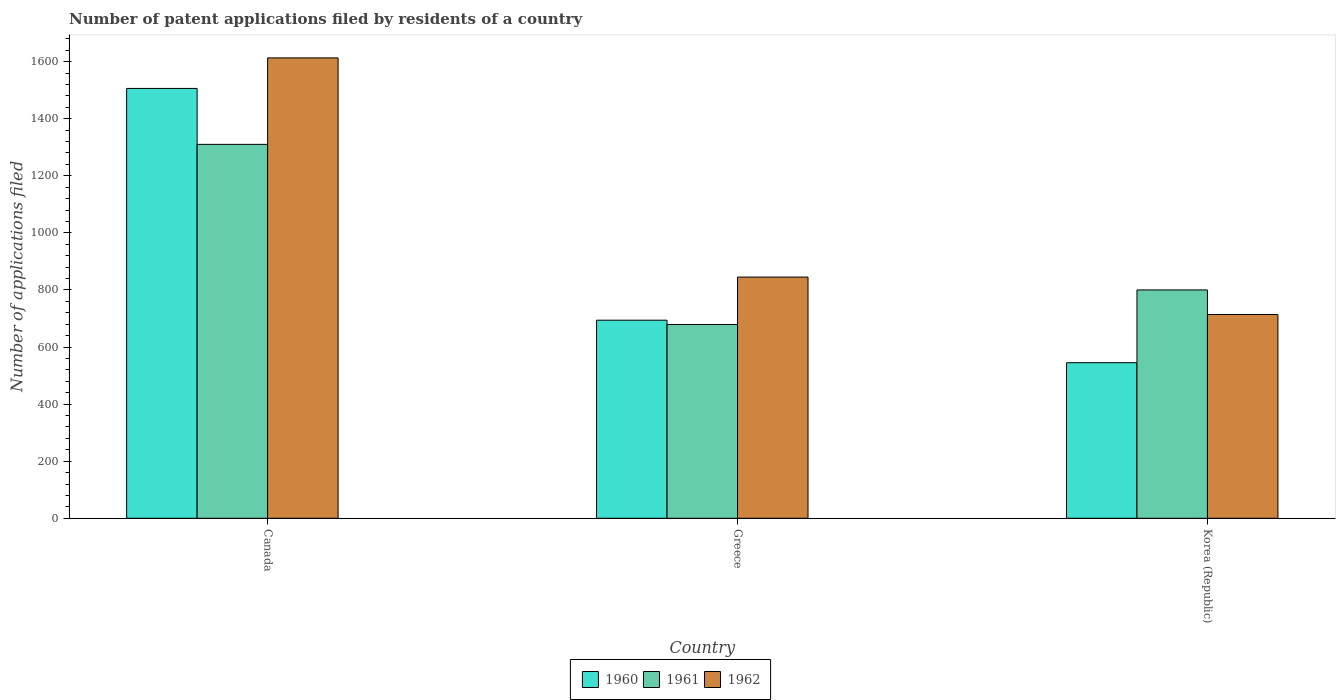Are the number of bars on each tick of the X-axis equal?
Provide a short and direct response. Yes. In how many cases, is the number of bars for a given country not equal to the number of legend labels?
Provide a succinct answer. 0. What is the number of applications filed in 1962 in Korea (Republic)?
Give a very brief answer. 714. Across all countries, what is the maximum number of applications filed in 1961?
Give a very brief answer. 1310. Across all countries, what is the minimum number of applications filed in 1961?
Your answer should be very brief. 679. What is the total number of applications filed in 1962 in the graph?
Make the answer very short. 3172. What is the difference between the number of applications filed in 1960 in Canada and that in Greece?
Your answer should be compact. 812. What is the difference between the number of applications filed in 1961 in Korea (Republic) and the number of applications filed in 1962 in Canada?
Offer a very short reply. -813. What is the average number of applications filed in 1961 per country?
Your answer should be compact. 929.67. What is the difference between the number of applications filed of/in 1962 and number of applications filed of/in 1961 in Canada?
Ensure brevity in your answer.  303. What is the ratio of the number of applications filed in 1962 in Canada to that in Korea (Republic)?
Your answer should be very brief. 2.26. What is the difference between the highest and the second highest number of applications filed in 1962?
Give a very brief answer. -131. What is the difference between the highest and the lowest number of applications filed in 1961?
Offer a very short reply. 631. Is the sum of the number of applications filed in 1961 in Canada and Korea (Republic) greater than the maximum number of applications filed in 1962 across all countries?
Provide a succinct answer. Yes. What does the 2nd bar from the right in Canada represents?
Your response must be concise. 1961. How many bars are there?
Your response must be concise. 9. Are all the bars in the graph horizontal?
Offer a terse response. No. How many countries are there in the graph?
Your answer should be very brief. 3. What is the difference between two consecutive major ticks on the Y-axis?
Make the answer very short. 200. Are the values on the major ticks of Y-axis written in scientific E-notation?
Your answer should be very brief. No. How many legend labels are there?
Provide a short and direct response. 3. What is the title of the graph?
Offer a very short reply. Number of patent applications filed by residents of a country. What is the label or title of the X-axis?
Make the answer very short. Country. What is the label or title of the Y-axis?
Provide a succinct answer. Number of applications filed. What is the Number of applications filed in 1960 in Canada?
Your answer should be compact. 1506. What is the Number of applications filed of 1961 in Canada?
Make the answer very short. 1310. What is the Number of applications filed in 1962 in Canada?
Provide a succinct answer. 1613. What is the Number of applications filed in 1960 in Greece?
Your response must be concise. 694. What is the Number of applications filed of 1961 in Greece?
Give a very brief answer. 679. What is the Number of applications filed in 1962 in Greece?
Offer a terse response. 845. What is the Number of applications filed of 1960 in Korea (Republic)?
Provide a succinct answer. 545. What is the Number of applications filed of 1961 in Korea (Republic)?
Offer a very short reply. 800. What is the Number of applications filed of 1962 in Korea (Republic)?
Your answer should be compact. 714. Across all countries, what is the maximum Number of applications filed in 1960?
Your response must be concise. 1506. Across all countries, what is the maximum Number of applications filed of 1961?
Provide a succinct answer. 1310. Across all countries, what is the maximum Number of applications filed of 1962?
Your answer should be compact. 1613. Across all countries, what is the minimum Number of applications filed in 1960?
Your answer should be very brief. 545. Across all countries, what is the minimum Number of applications filed in 1961?
Provide a short and direct response. 679. Across all countries, what is the minimum Number of applications filed of 1962?
Offer a terse response. 714. What is the total Number of applications filed of 1960 in the graph?
Ensure brevity in your answer.  2745. What is the total Number of applications filed of 1961 in the graph?
Offer a terse response. 2789. What is the total Number of applications filed of 1962 in the graph?
Ensure brevity in your answer.  3172. What is the difference between the Number of applications filed in 1960 in Canada and that in Greece?
Make the answer very short. 812. What is the difference between the Number of applications filed in 1961 in Canada and that in Greece?
Your answer should be compact. 631. What is the difference between the Number of applications filed in 1962 in Canada and that in Greece?
Give a very brief answer. 768. What is the difference between the Number of applications filed in 1960 in Canada and that in Korea (Republic)?
Ensure brevity in your answer.  961. What is the difference between the Number of applications filed of 1961 in Canada and that in Korea (Republic)?
Give a very brief answer. 510. What is the difference between the Number of applications filed of 1962 in Canada and that in Korea (Republic)?
Provide a short and direct response. 899. What is the difference between the Number of applications filed in 1960 in Greece and that in Korea (Republic)?
Ensure brevity in your answer.  149. What is the difference between the Number of applications filed of 1961 in Greece and that in Korea (Republic)?
Your response must be concise. -121. What is the difference between the Number of applications filed in 1962 in Greece and that in Korea (Republic)?
Give a very brief answer. 131. What is the difference between the Number of applications filed of 1960 in Canada and the Number of applications filed of 1961 in Greece?
Keep it short and to the point. 827. What is the difference between the Number of applications filed of 1960 in Canada and the Number of applications filed of 1962 in Greece?
Offer a terse response. 661. What is the difference between the Number of applications filed in 1961 in Canada and the Number of applications filed in 1962 in Greece?
Offer a very short reply. 465. What is the difference between the Number of applications filed of 1960 in Canada and the Number of applications filed of 1961 in Korea (Republic)?
Ensure brevity in your answer.  706. What is the difference between the Number of applications filed of 1960 in Canada and the Number of applications filed of 1962 in Korea (Republic)?
Your answer should be very brief. 792. What is the difference between the Number of applications filed in 1961 in Canada and the Number of applications filed in 1962 in Korea (Republic)?
Provide a succinct answer. 596. What is the difference between the Number of applications filed of 1960 in Greece and the Number of applications filed of 1961 in Korea (Republic)?
Offer a terse response. -106. What is the difference between the Number of applications filed in 1961 in Greece and the Number of applications filed in 1962 in Korea (Republic)?
Give a very brief answer. -35. What is the average Number of applications filed of 1960 per country?
Make the answer very short. 915. What is the average Number of applications filed of 1961 per country?
Provide a short and direct response. 929.67. What is the average Number of applications filed in 1962 per country?
Your response must be concise. 1057.33. What is the difference between the Number of applications filed in 1960 and Number of applications filed in 1961 in Canada?
Keep it short and to the point. 196. What is the difference between the Number of applications filed of 1960 and Number of applications filed of 1962 in Canada?
Provide a short and direct response. -107. What is the difference between the Number of applications filed in 1961 and Number of applications filed in 1962 in Canada?
Offer a very short reply. -303. What is the difference between the Number of applications filed of 1960 and Number of applications filed of 1962 in Greece?
Keep it short and to the point. -151. What is the difference between the Number of applications filed in 1961 and Number of applications filed in 1962 in Greece?
Ensure brevity in your answer.  -166. What is the difference between the Number of applications filed in 1960 and Number of applications filed in 1961 in Korea (Republic)?
Your answer should be compact. -255. What is the difference between the Number of applications filed of 1960 and Number of applications filed of 1962 in Korea (Republic)?
Give a very brief answer. -169. What is the difference between the Number of applications filed in 1961 and Number of applications filed in 1962 in Korea (Republic)?
Your answer should be very brief. 86. What is the ratio of the Number of applications filed of 1960 in Canada to that in Greece?
Give a very brief answer. 2.17. What is the ratio of the Number of applications filed in 1961 in Canada to that in Greece?
Give a very brief answer. 1.93. What is the ratio of the Number of applications filed of 1962 in Canada to that in Greece?
Your answer should be very brief. 1.91. What is the ratio of the Number of applications filed of 1960 in Canada to that in Korea (Republic)?
Your answer should be compact. 2.76. What is the ratio of the Number of applications filed of 1961 in Canada to that in Korea (Republic)?
Offer a terse response. 1.64. What is the ratio of the Number of applications filed of 1962 in Canada to that in Korea (Republic)?
Your response must be concise. 2.26. What is the ratio of the Number of applications filed in 1960 in Greece to that in Korea (Republic)?
Keep it short and to the point. 1.27. What is the ratio of the Number of applications filed in 1961 in Greece to that in Korea (Republic)?
Offer a terse response. 0.85. What is the ratio of the Number of applications filed of 1962 in Greece to that in Korea (Republic)?
Give a very brief answer. 1.18. What is the difference between the highest and the second highest Number of applications filed in 1960?
Your response must be concise. 812. What is the difference between the highest and the second highest Number of applications filed in 1961?
Provide a succinct answer. 510. What is the difference between the highest and the second highest Number of applications filed in 1962?
Ensure brevity in your answer.  768. What is the difference between the highest and the lowest Number of applications filed of 1960?
Your answer should be very brief. 961. What is the difference between the highest and the lowest Number of applications filed of 1961?
Your response must be concise. 631. What is the difference between the highest and the lowest Number of applications filed in 1962?
Provide a short and direct response. 899. 